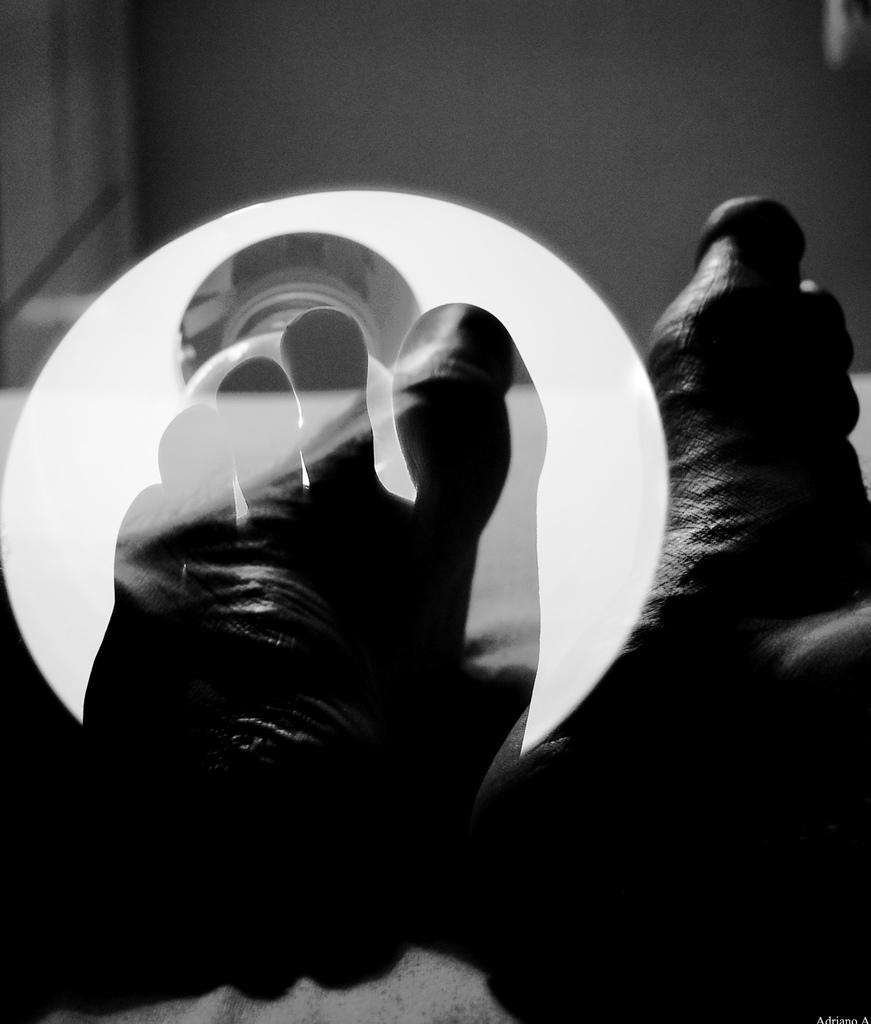Describe this image in one or two sentences. It is the black and white image in which there is a leg in front of the bulb. On the right side there is another leg. 